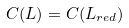Convert formula to latex. <formula><loc_0><loc_0><loc_500><loc_500>C ( L ) = C ( L _ { r e d } )</formula> 